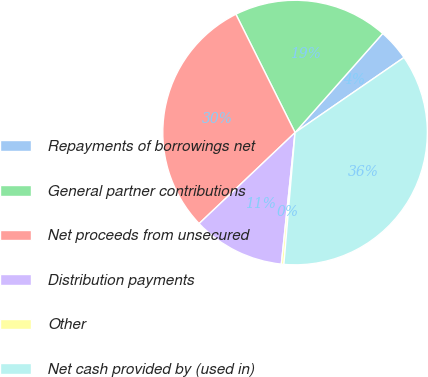Convert chart to OTSL. <chart><loc_0><loc_0><loc_500><loc_500><pie_chart><fcel>Repayments of borrowings net<fcel>General partner contributions<fcel>Net proceeds from unsecured<fcel>Distribution payments<fcel>Other<fcel>Net cash provided by (used in)<nl><fcel>3.87%<fcel>18.91%<fcel>29.7%<fcel>11.26%<fcel>0.31%<fcel>35.95%<nl></chart> 